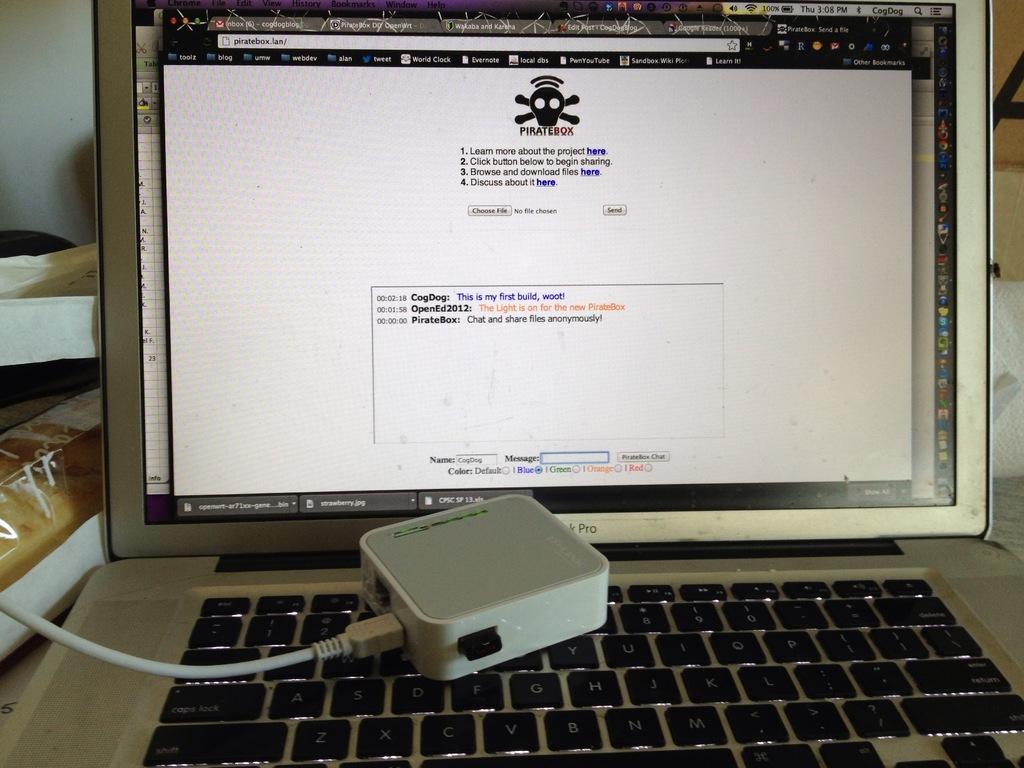What is the name of the open webpage?
Provide a short and direct response. Piratebox. What is the brand of this laptop?
Make the answer very short. Unanswerable. 